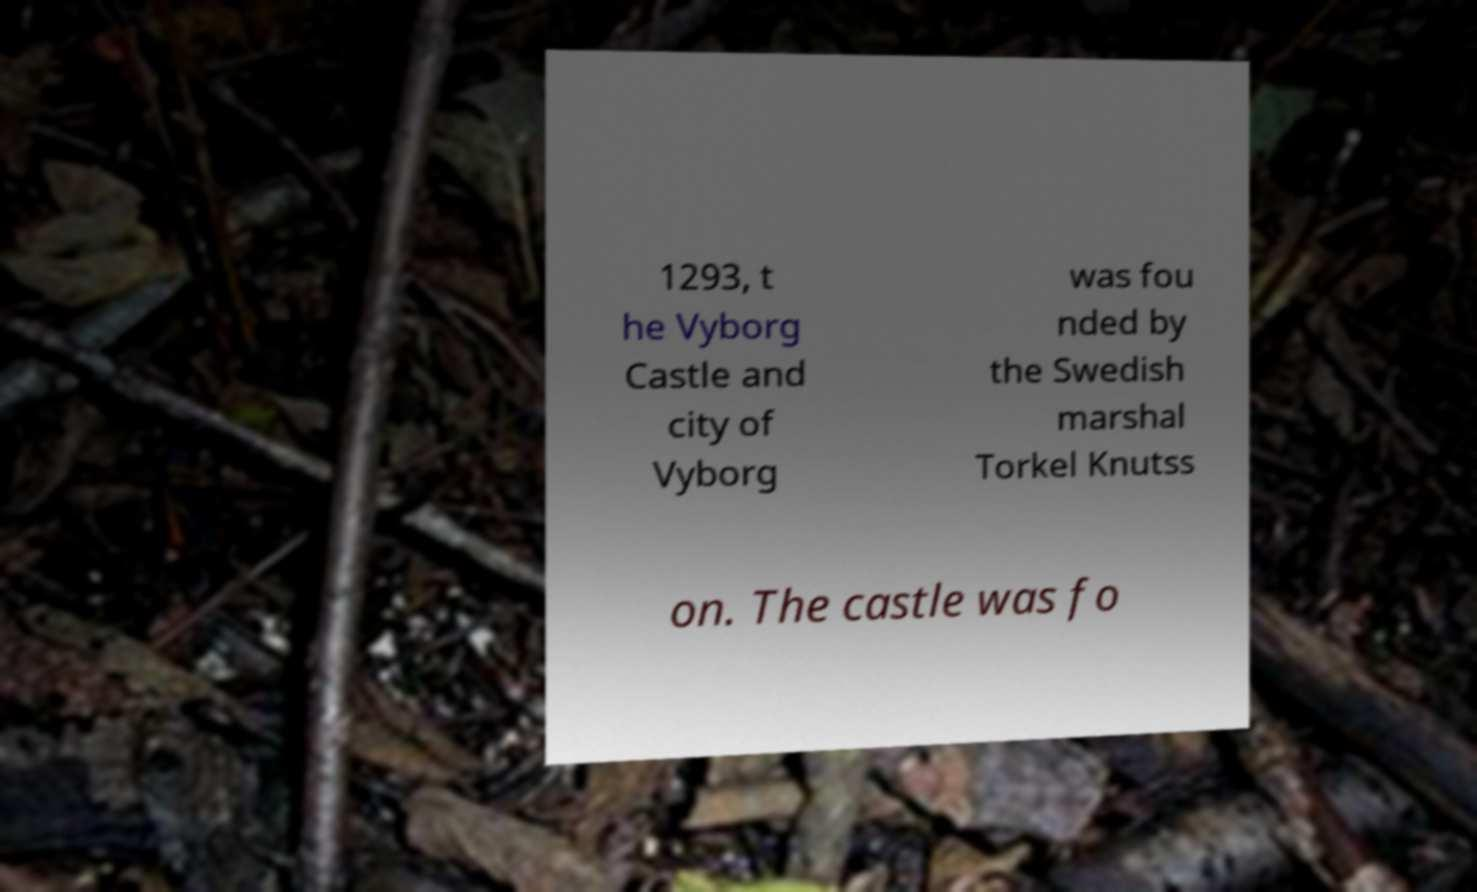Please read and relay the text visible in this image. What does it say? 1293, t he Vyborg Castle and city of Vyborg was fou nded by the Swedish marshal Torkel Knutss on. The castle was fo 